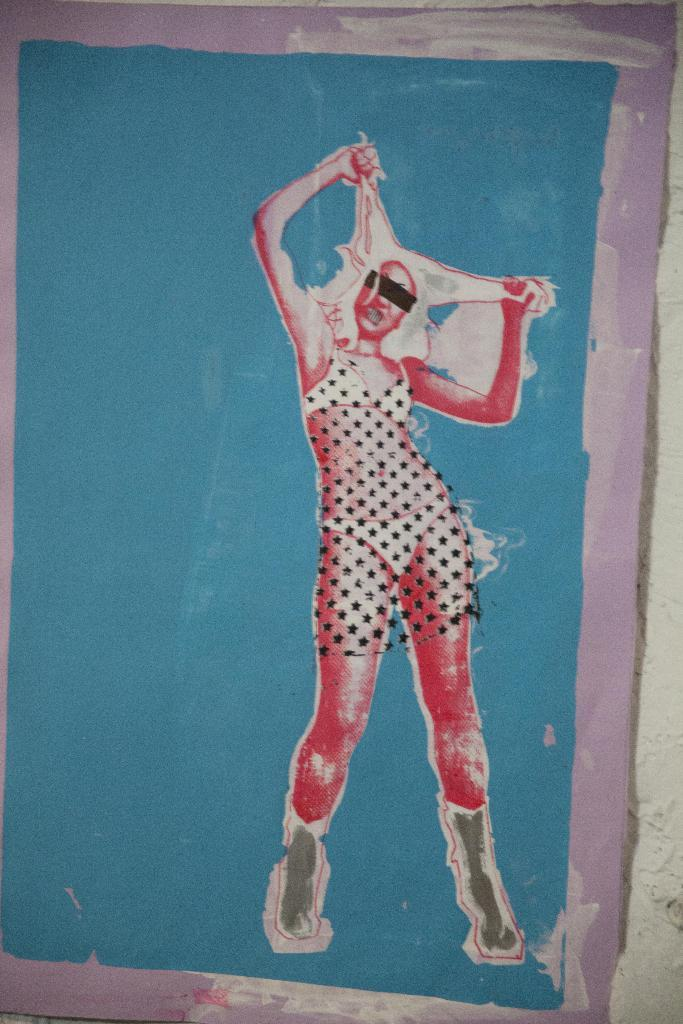What is on the wall in the image? There is a painting on the wall in the image. What is depicted in the painting? The painting contains an image of a lady. What type of property does the lady own in the image? There is no information about the lady's property in the image. Can you tell me how the lady's dad is involved in the painting? There is no mention of the lady's dad in the image or the painting. 